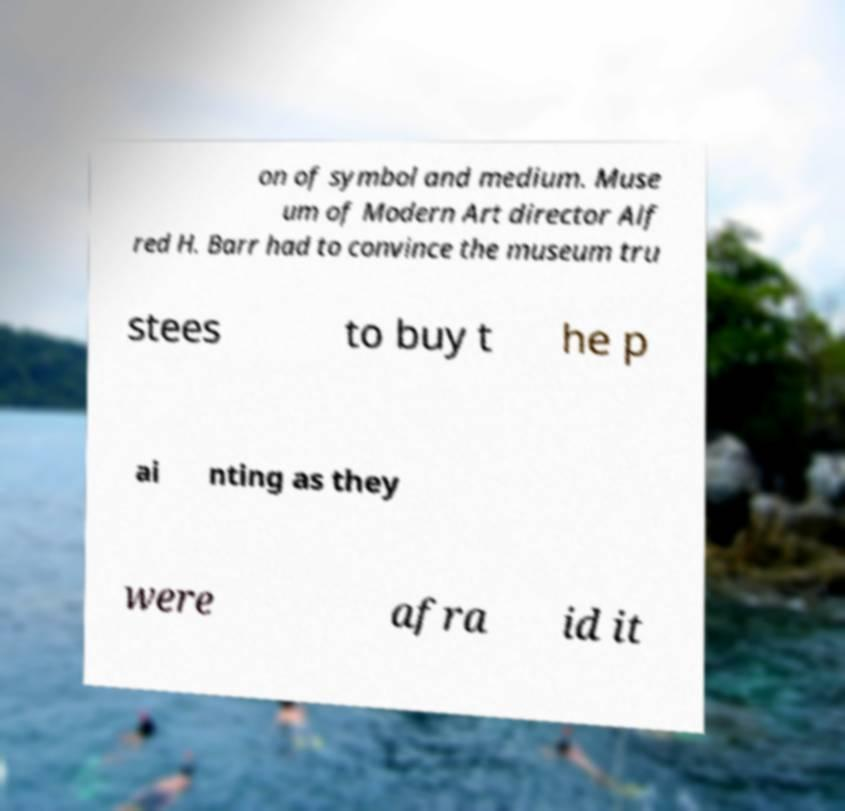For documentation purposes, I need the text within this image transcribed. Could you provide that? on of symbol and medium. Muse um of Modern Art director Alf red H. Barr had to convince the museum tru stees to buy t he p ai nting as they were afra id it 